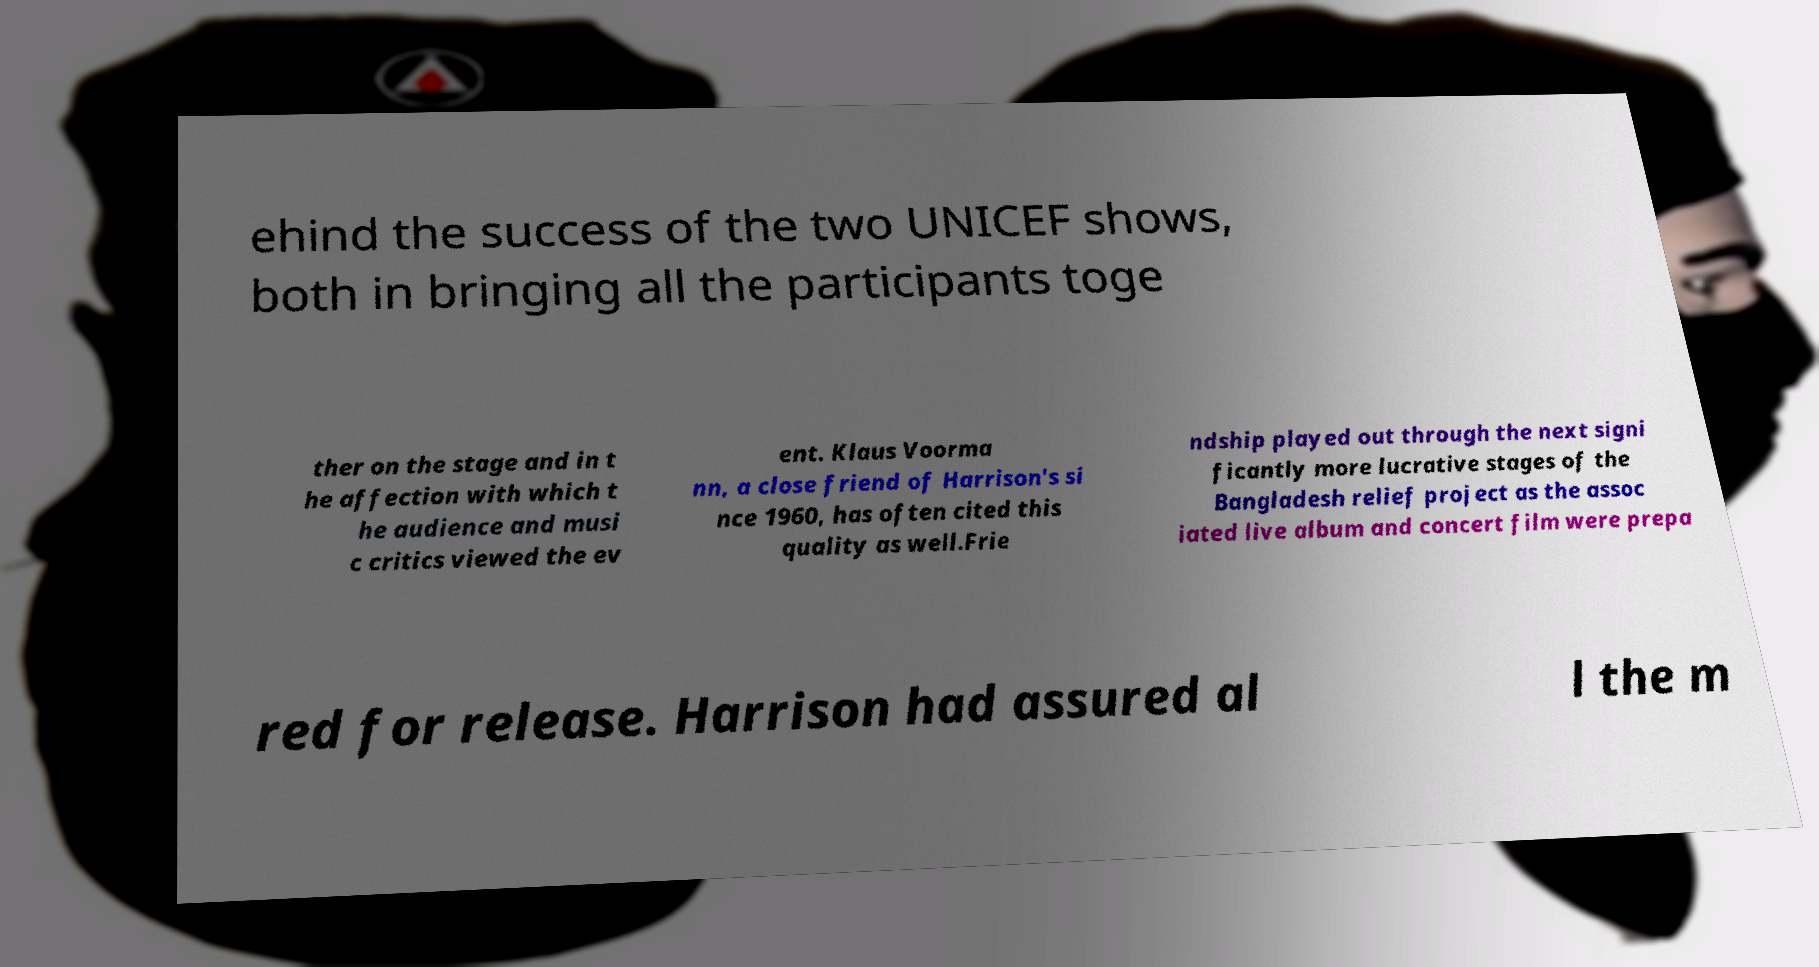For documentation purposes, I need the text within this image transcribed. Could you provide that? ehind the success of the two UNICEF shows, both in bringing all the participants toge ther on the stage and in t he affection with which t he audience and musi c critics viewed the ev ent. Klaus Voorma nn, a close friend of Harrison's si nce 1960, has often cited this quality as well.Frie ndship played out through the next signi ficantly more lucrative stages of the Bangladesh relief project as the assoc iated live album and concert film were prepa red for release. Harrison had assured al l the m 